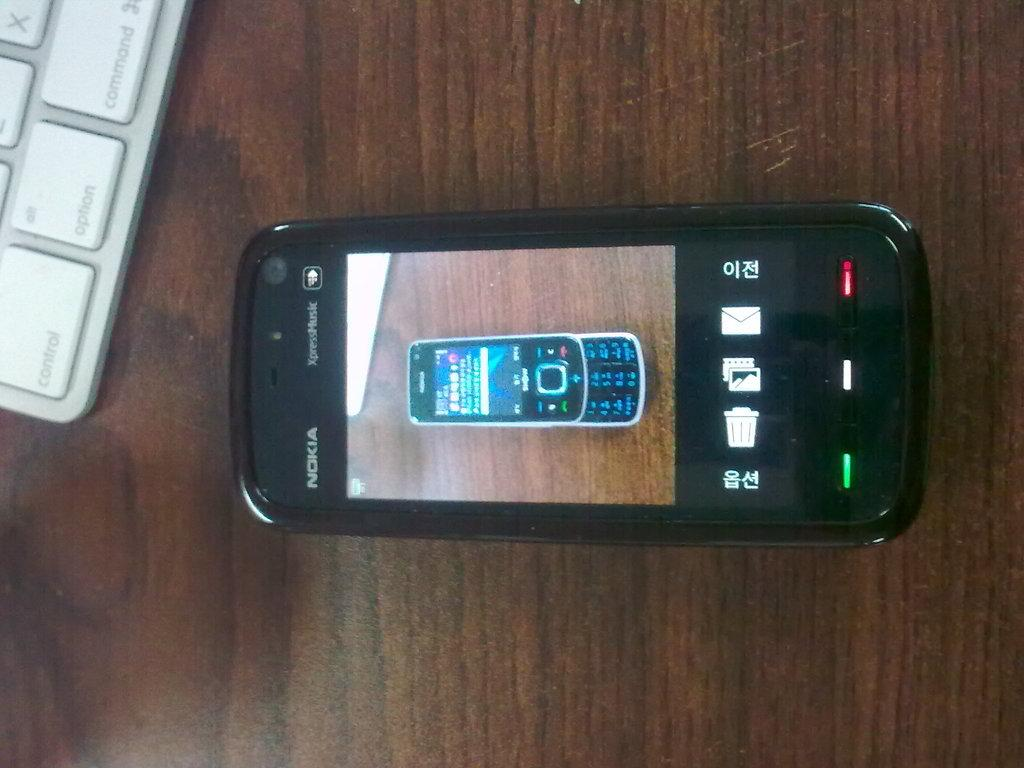What type of table is in the image? There is a brown table in the image. What electronic device is on the table? There is a mobile phone on the table. What other object can be seen on the table? There is a keyboard with a white color on the table. How does the room feel in terms of noise level in the image? The image does not provide information about the noise level in the room. What emotion is the table expressing towards the mobile phone in the image? The table is an inanimate object and does not have emotions or the ability to express hate or any other emotion. 